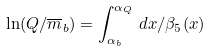<formula> <loc_0><loc_0><loc_500><loc_500>\ln ( Q / \overline { m } _ { b } ) = \int ^ { \alpha _ { Q } } _ { \alpha _ { b } } \, d x / \beta _ { 5 } ( x )</formula> 